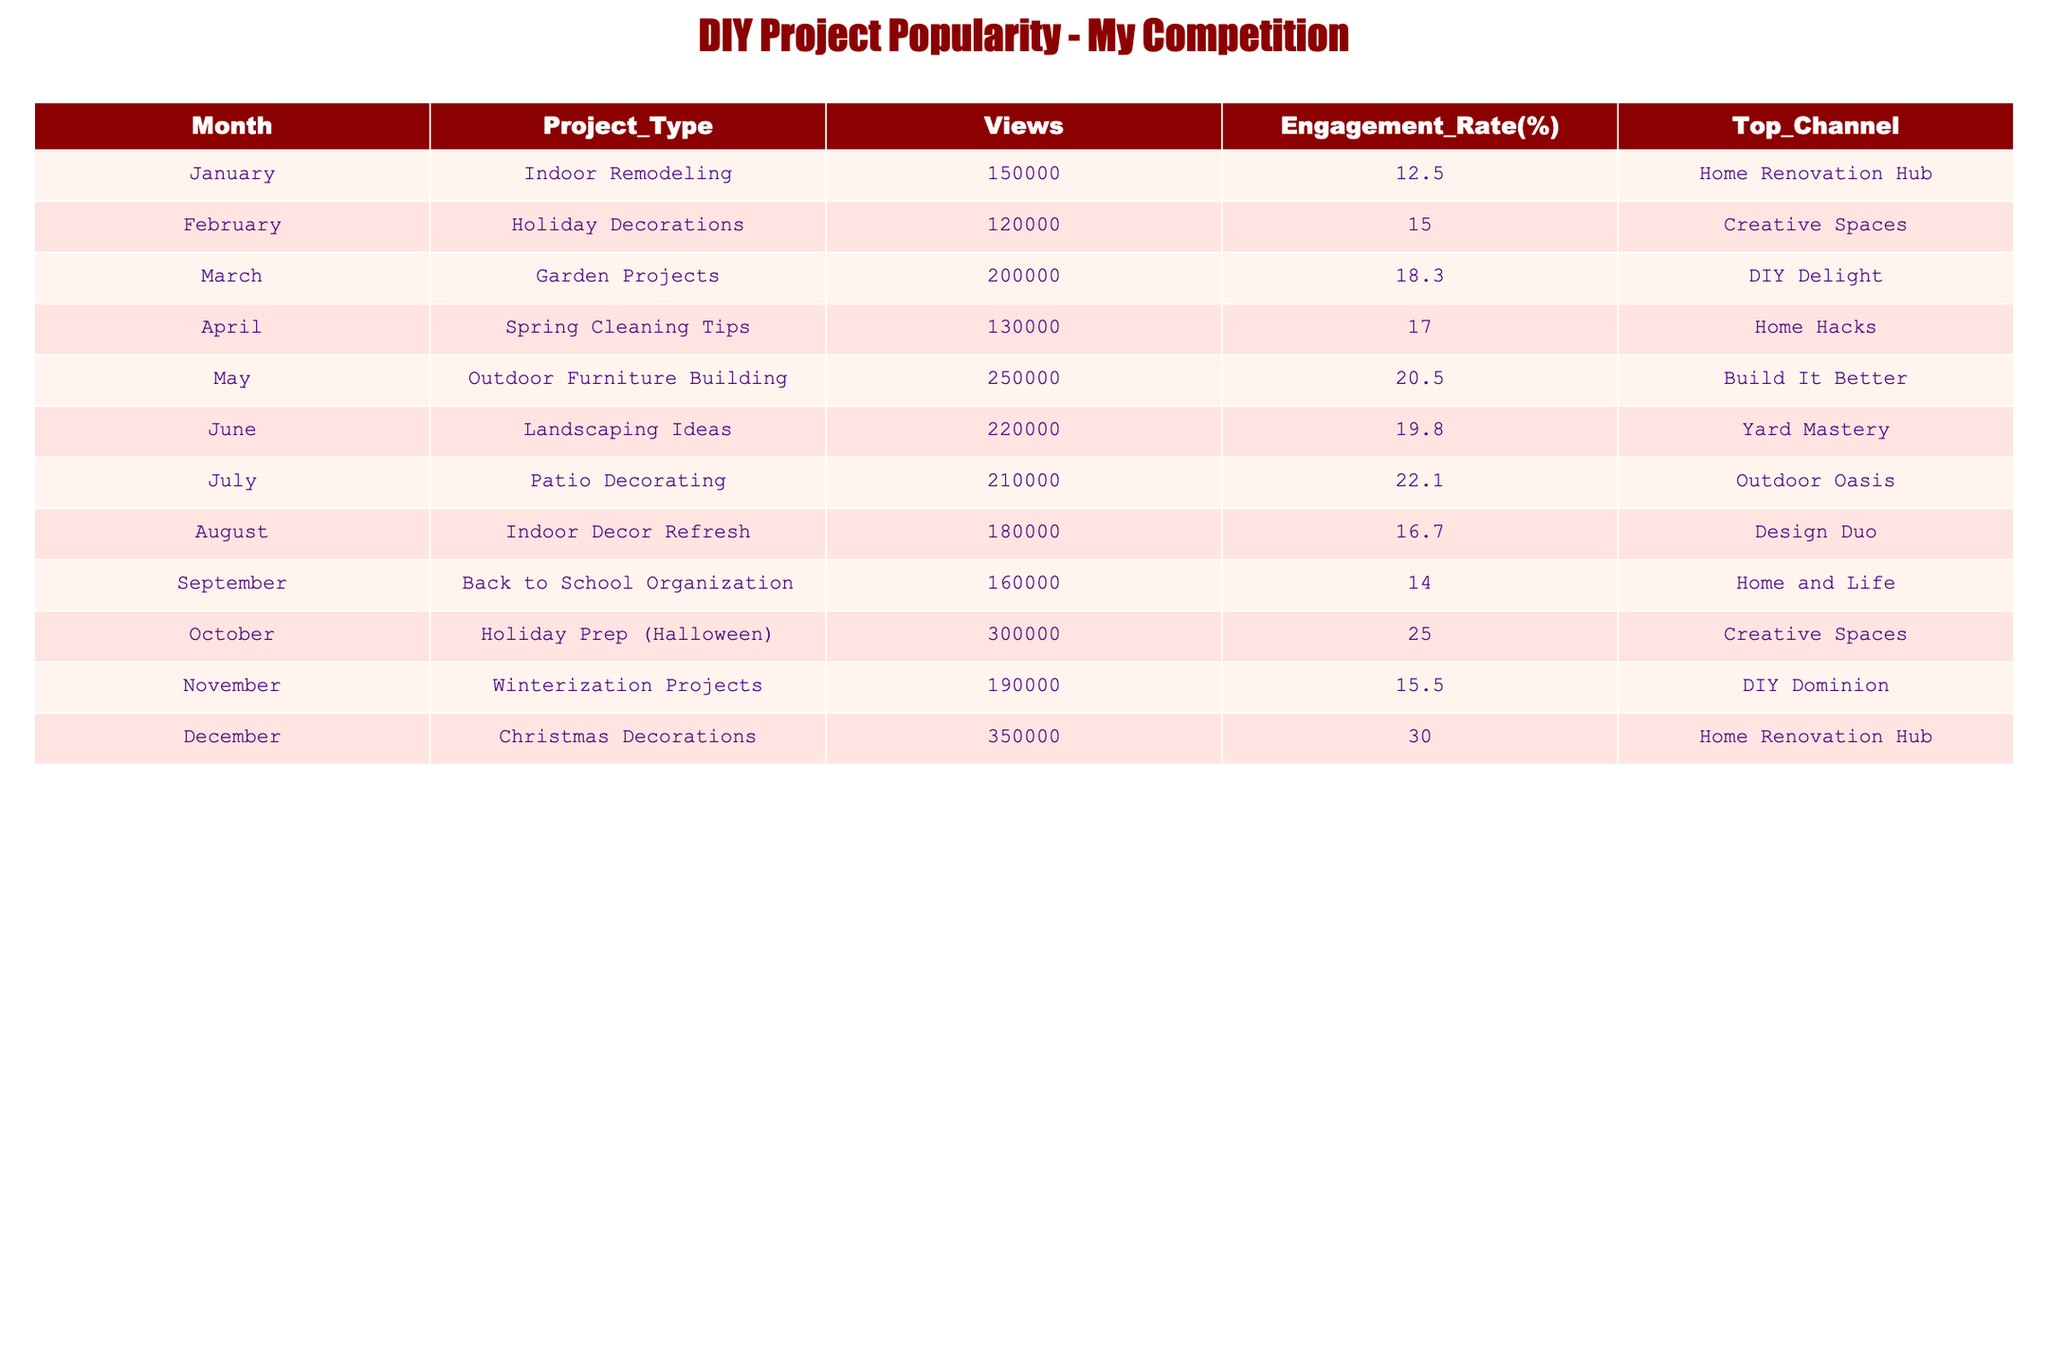What is the project type with the highest views? By examining the "Views" column, we find the highest number of views listed is 350000 for "Christmas Decorations."
Answer: Christmas Decorations Which month had the lowest engagement rate? The engagement rates are listed in the "Engagement Rate(%)" column. The lowest value is 12.5%, which corresponds to "Indoor Remodeling" in January.
Answer: January What is the average engagement rate for the projects from May to August? We will sum the engagement rates from May (20.5), June (19.8), July (22.1), and August (16.7). The total is 79.1. Dividing this by the number of months (4) gives us an average of 79.1/4 = 19.775%.
Answer: 19.775 Is there a project type in October with an engagement rate higher than 20%? The engagement rate for "Holiday Prep (Halloween)" in October is 25.0%. Thus, it is higher than 20%.
Answer: Yes In which month did "DIY Delight" achieve its highest popularity? "DIY Delight" is the top channel listed for "Garden Projects" in March, which has 200000 views, and is the only month tied to this channel in the dataset.
Answer: March What are the top views for projects related to outdoor themes? We look at the relevant project types: "Outdoor Furniture Building" (250000) in May and "Landscaping Ideas" (220000) in June. The highest views among these is 250000 in May.
Answer: 250000 How many views did the project type with the lowest views receive? The lowest views in the data is "Holiday Decorations," which received 120000 views in February.
Answer: 120000 What project type had the highest views in the summer months (June to August)? The relevant project types during these months are "Landscaping Ideas" (220000), "Patio Decorating" (210000), and "Indoor Decor Refresh" (180000). The highest among these is 220000 for "Landscaping Ideas."
Answer: Landscaping Ideas Which channel had the highest engagement rate for a project in December? In December, "Home Renovation Hub" featured "Christmas Decorations" with an engagement rate of 30.0%, which is noted as the highest for that month.
Answer: Home Renovation Hub 